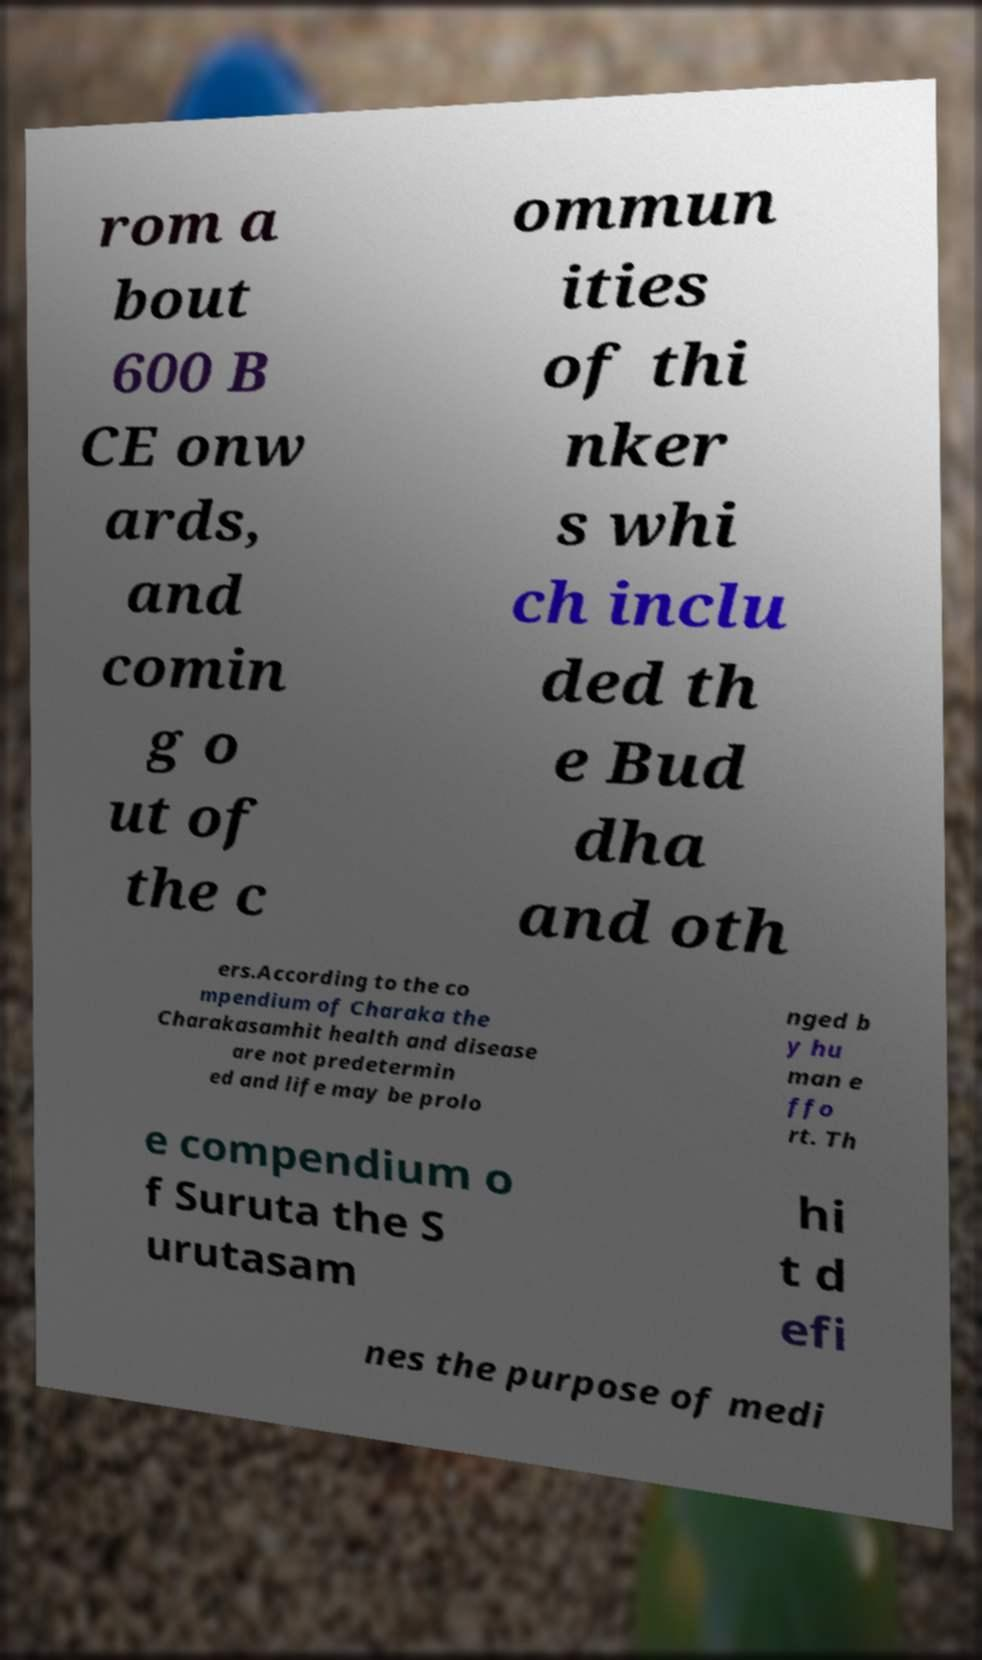Could you extract and type out the text from this image? rom a bout 600 B CE onw ards, and comin g o ut of the c ommun ities of thi nker s whi ch inclu ded th e Bud dha and oth ers.According to the co mpendium of Charaka the Charakasamhit health and disease are not predetermin ed and life may be prolo nged b y hu man e ffo rt. Th e compendium o f Suruta the S urutasam hi t d efi nes the purpose of medi 